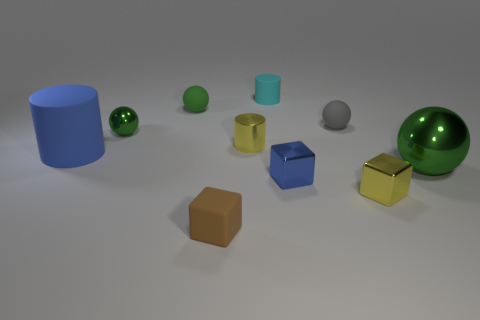Are there any small rubber objects that are in front of the green ball that is behind the green metallic ball that is to the left of the big green thing? yes 